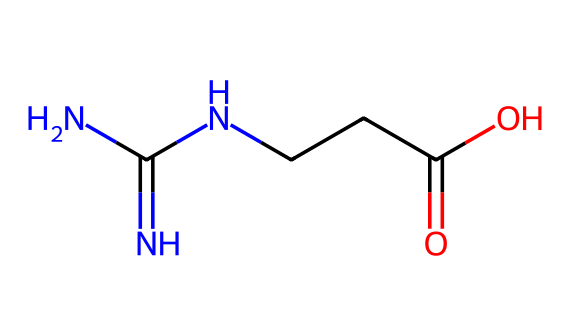What is the molecular formula of creatine? The SMILES representation starts with "NC(=N)N", indicating there are nitrogen and carbon atoms present. The rest "CCC(=O)O" suggests additional carbon and oxygen atoms, leading to a total count of C, H, N, and O. The resulting molecular formula is C4H9N3O2.
Answer: C4H9N3O2 How many nitrogen atoms are in creatine? In the SMILES representation, we can see "N" appears three times before the carbon chain, indicating a total of three nitrogen atoms in the structure.
Answer: 3 What type of functional group is present in creatine? Within the SMILES structure, "C(=O)O" indicates the presence of a carboxylic acid functional group, characterized by the carbonyl (C=O) and hydroxyl (O-H) components bonded to the same carbon atom.
Answer: carboxylic acid What role do the nitrogen atoms play in creatine? The nitrogen atoms in creatine are part of the guanidine group (NC(=N)N), which is crucial for its role in energy metabolism and muscle strength, as they contribute to the structure's ability to donate phosphate groups for ATP synthesis during exercise.
Answer: energy metabolism What is the significance of the carboxyl group in creatine? The carboxyl group (CCC(=O)O) in creatine influences the molecule's solubility and its ability to participate in biochemical reactions, particularly in energy transfer via creatine phosphate, which is vital for quick energy during high-intensity workouts.
Answer: solubility and energy transfer 